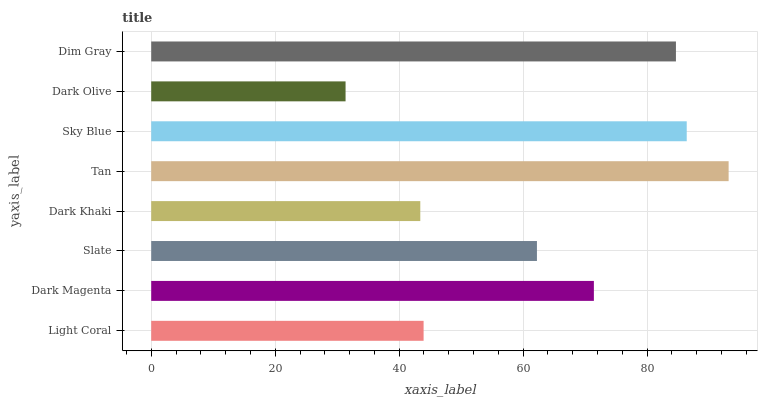Is Dark Olive the minimum?
Answer yes or no. Yes. Is Tan the maximum?
Answer yes or no. Yes. Is Dark Magenta the minimum?
Answer yes or no. No. Is Dark Magenta the maximum?
Answer yes or no. No. Is Dark Magenta greater than Light Coral?
Answer yes or no. Yes. Is Light Coral less than Dark Magenta?
Answer yes or no. Yes. Is Light Coral greater than Dark Magenta?
Answer yes or no. No. Is Dark Magenta less than Light Coral?
Answer yes or no. No. Is Dark Magenta the high median?
Answer yes or no. Yes. Is Slate the low median?
Answer yes or no. Yes. Is Slate the high median?
Answer yes or no. No. Is Dark Khaki the low median?
Answer yes or no. No. 